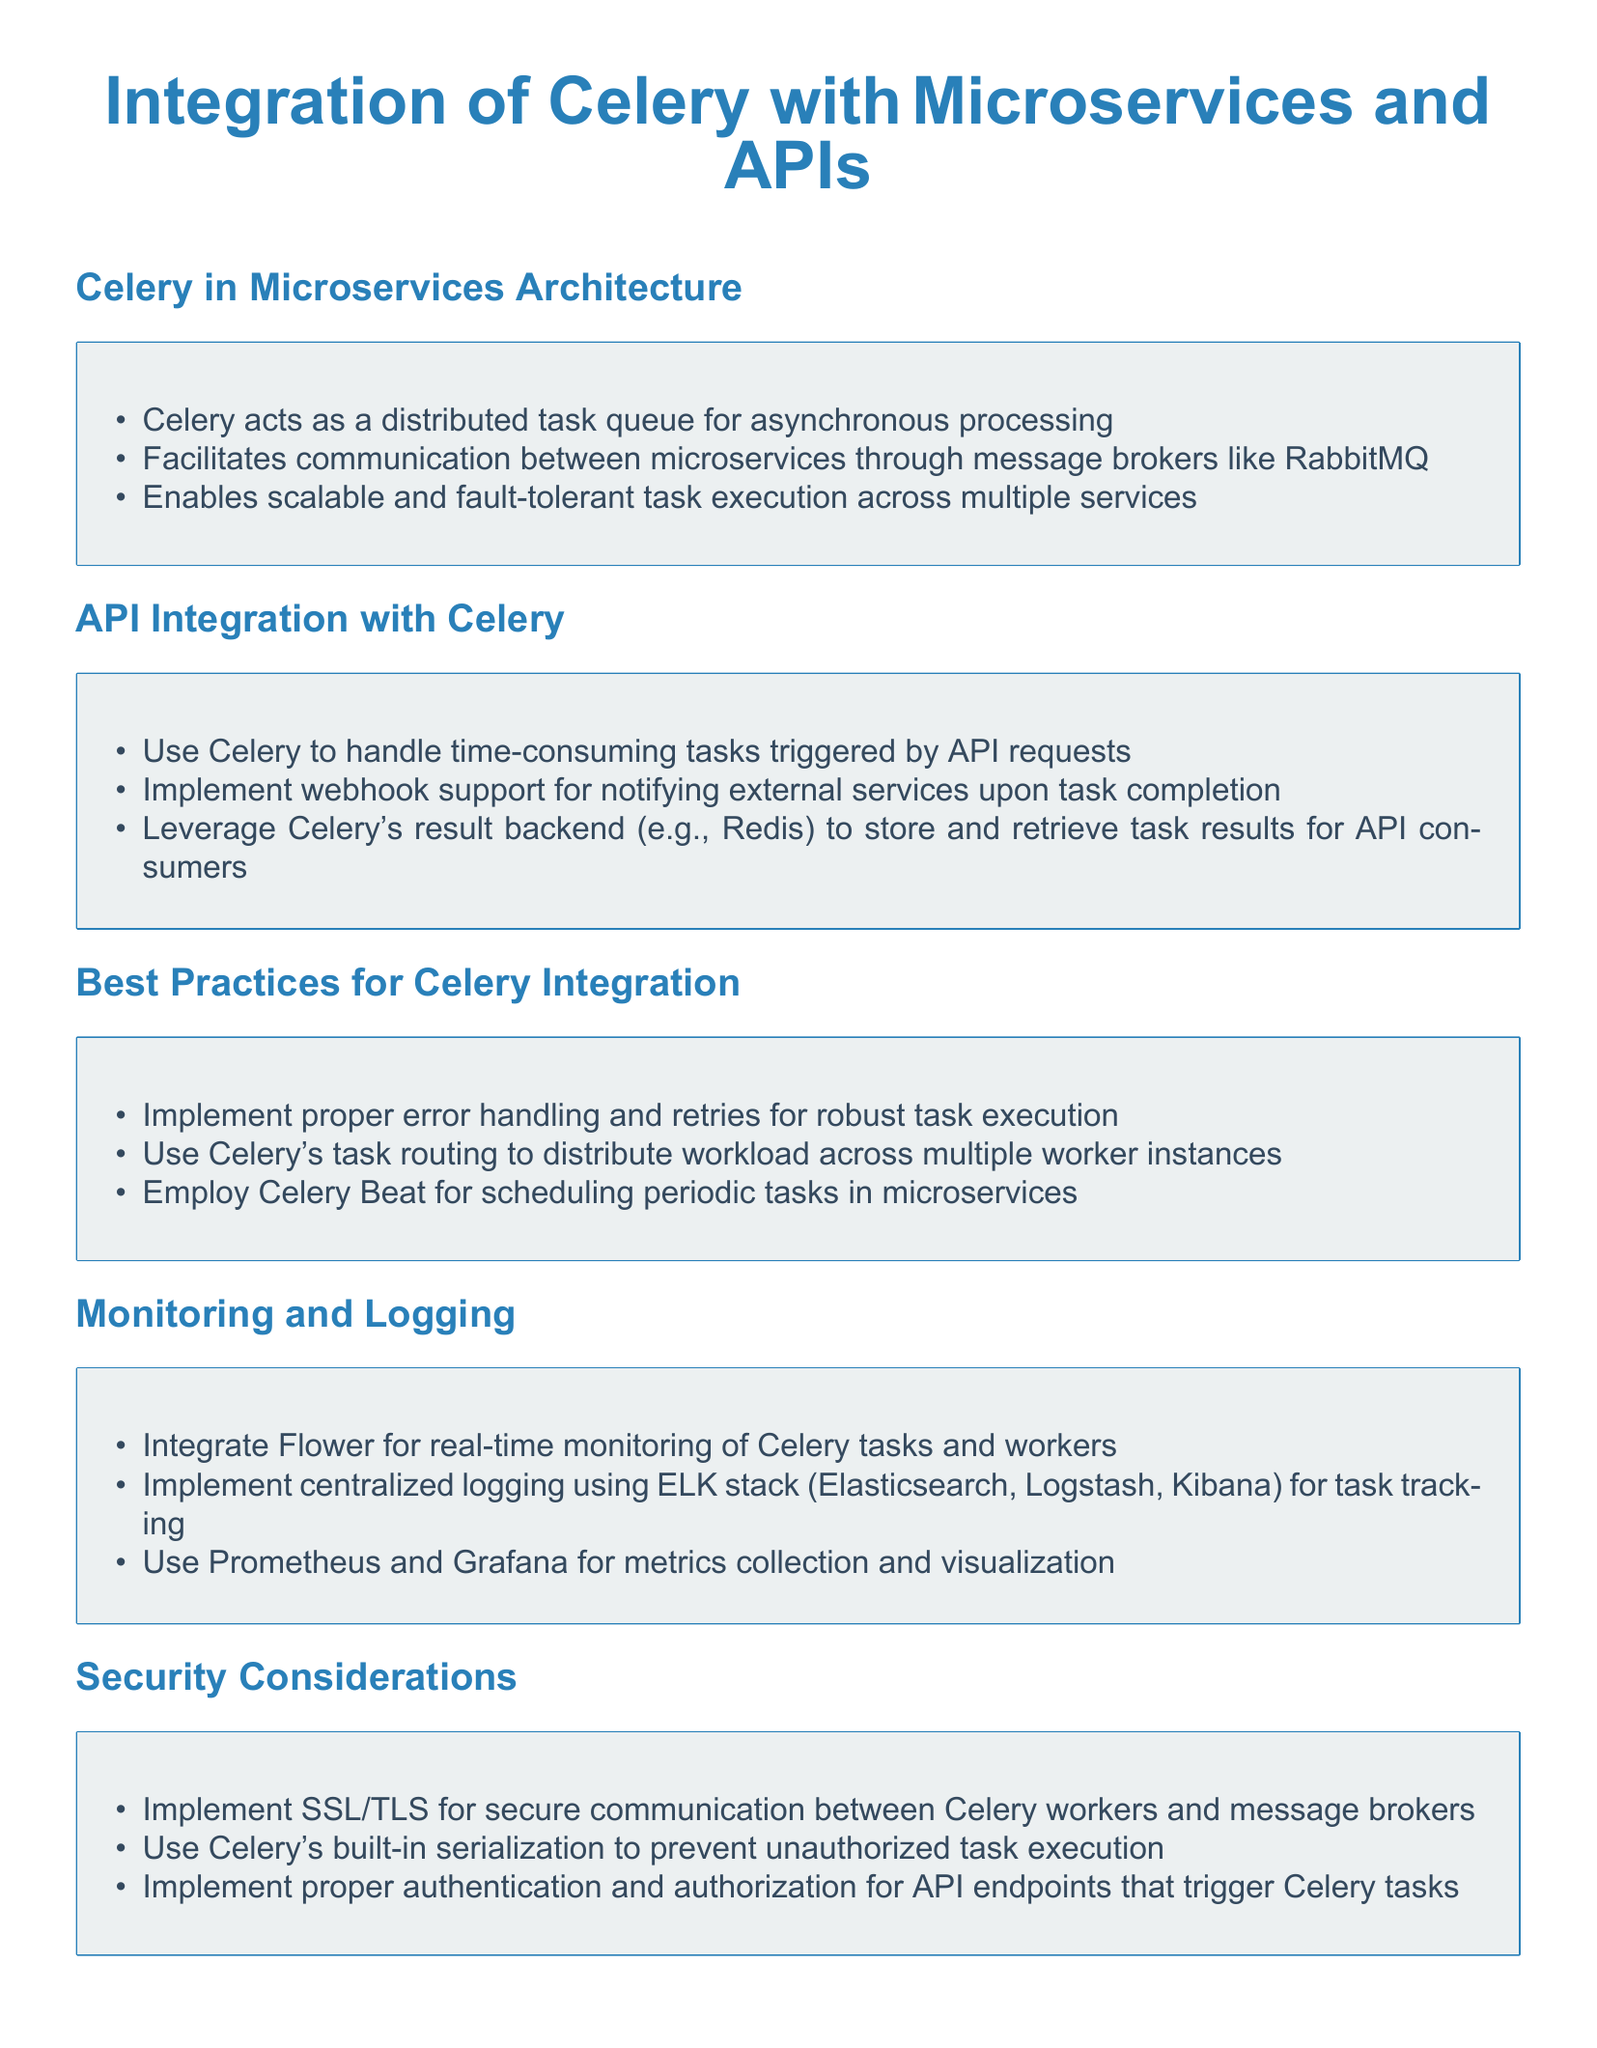What is the role of Celery in microservices architecture? Celery acts as a distributed task queue for asynchronous processing.
Answer: distributed task queue What message broker is mentioned for facilitating communication? The document specifies RabbitMQ as a message broker used for communication between microservices.
Answer: RabbitMQ What is a recommended tool for real-time monitoring of Celery tasks? The document suggests integrating Flower for real-time monitoring of Celery tasks and workers.
Answer: Flower What backend is suggested for storing task results? The document mentions using Redis as a result backend to store and retrieve task results.
Answer: Redis Which stack is recommended for centralized logging? The document recommends using the ELK stack (Elasticsearch, Logstash, Kibana) for centralized logging.
Answer: ELK stack What type of tasks does Celery handle that are triggered by APIs? The document states that Celery handles time-consuming tasks triggered by API requests.
Answer: time-consuming tasks What security protocol should be implemented for Celery workers? The document advises implementing SSL/TLS for secure communication.
Answer: SSL/TLS What is the function of Celery Beat in microservices? Celery Beat is employed for scheduling periodic tasks in microservices.
Answer: scheduling periodic tasks What should be implemented for API endpoints triggering Celery tasks? Proper authentication and authorization should be implemented for security.
Answer: authentication and authorization 